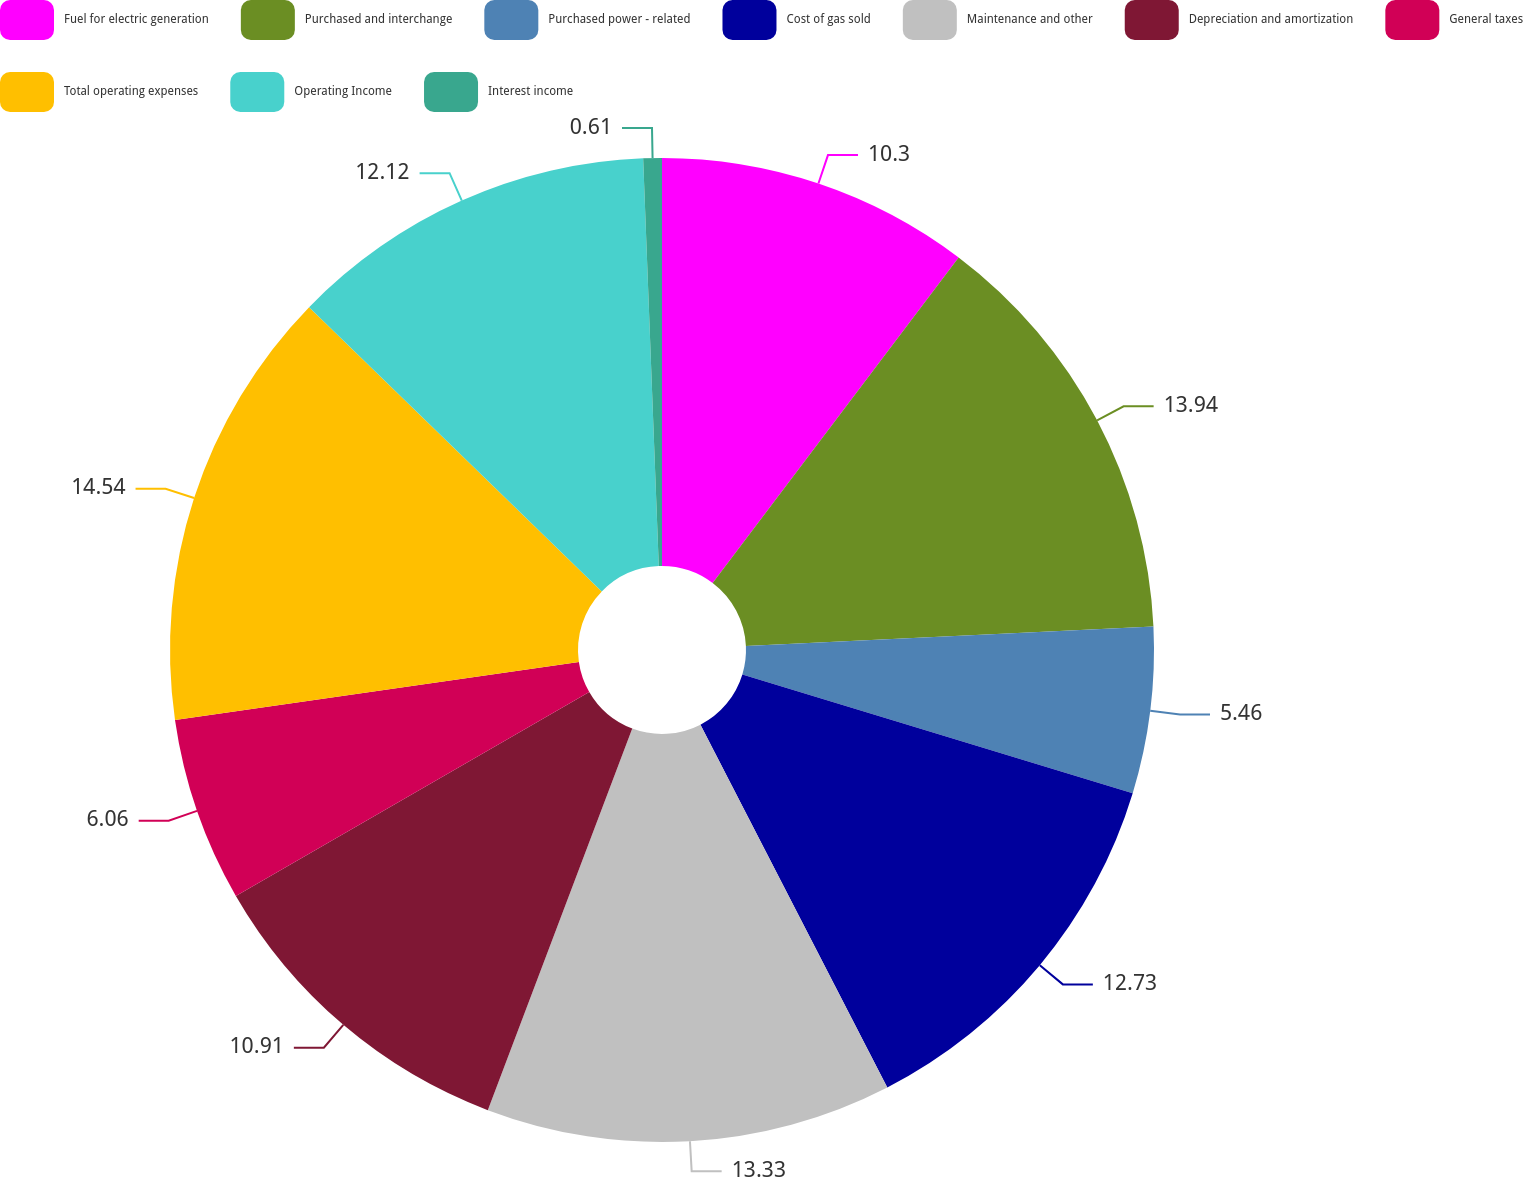<chart> <loc_0><loc_0><loc_500><loc_500><pie_chart><fcel>Fuel for electric generation<fcel>Purchased and interchange<fcel>Purchased power - related<fcel>Cost of gas sold<fcel>Maintenance and other<fcel>Depreciation and amortization<fcel>General taxes<fcel>Total operating expenses<fcel>Operating Income<fcel>Interest income<nl><fcel>10.3%<fcel>13.94%<fcel>5.46%<fcel>12.73%<fcel>13.33%<fcel>10.91%<fcel>6.06%<fcel>14.54%<fcel>12.12%<fcel>0.61%<nl></chart> 